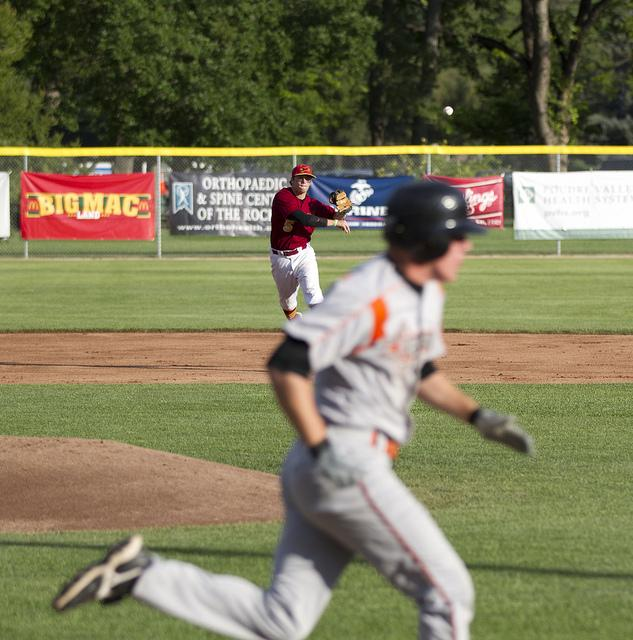Why is the player blurry? Please explain your reasoning. moving fast. He is running. 